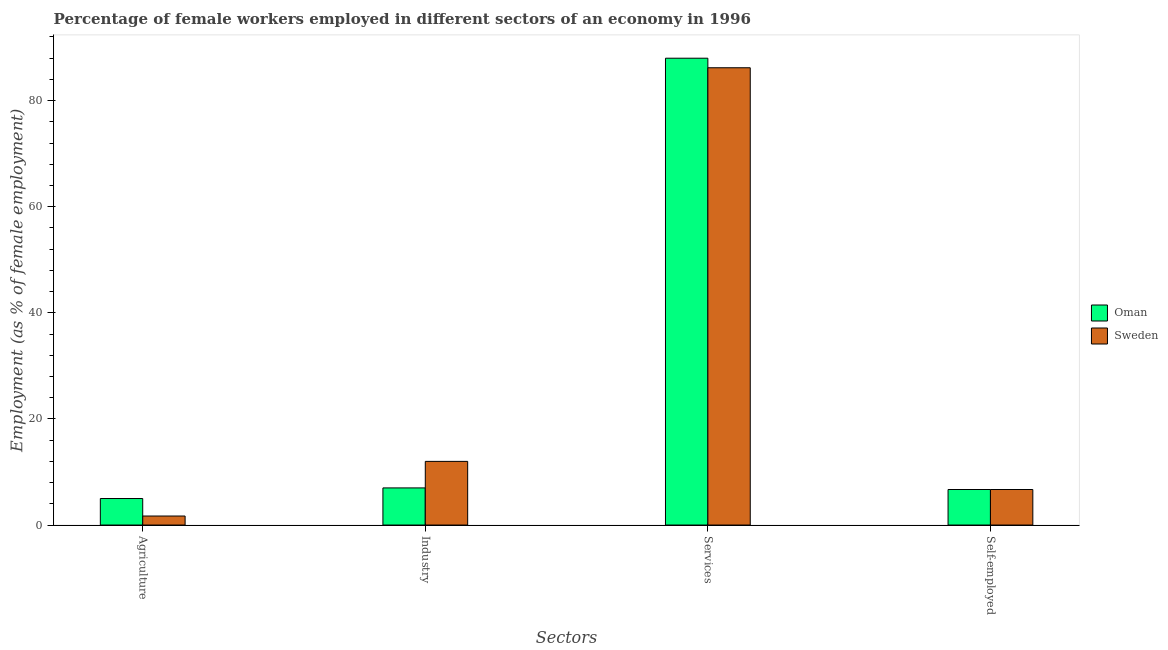Are the number of bars per tick equal to the number of legend labels?
Give a very brief answer. Yes. Are the number of bars on each tick of the X-axis equal?
Offer a terse response. Yes. How many bars are there on the 2nd tick from the left?
Provide a succinct answer. 2. How many bars are there on the 1st tick from the right?
Give a very brief answer. 2. What is the label of the 4th group of bars from the left?
Offer a very short reply. Self-employed. What is the percentage of self employed female workers in Oman?
Offer a terse response. 6.7. In which country was the percentage of female workers in services maximum?
Give a very brief answer. Oman. In which country was the percentage of female workers in services minimum?
Give a very brief answer. Sweden. What is the total percentage of female workers in agriculture in the graph?
Offer a very short reply. 6.7. What is the difference between the percentage of female workers in services in Oman and that in Sweden?
Make the answer very short. 1.8. What is the difference between the percentage of female workers in agriculture in Oman and the percentage of female workers in services in Sweden?
Give a very brief answer. -81.2. What is the average percentage of female workers in services per country?
Offer a terse response. 87.1. What is the difference between the percentage of female workers in industry and percentage of self employed female workers in Sweden?
Give a very brief answer. 5.3. In how many countries, is the percentage of female workers in industry greater than 36 %?
Your answer should be very brief. 0. What is the ratio of the percentage of female workers in industry in Oman to that in Sweden?
Provide a succinct answer. 0.58. Is the percentage of female workers in industry in Oman less than that in Sweden?
Your response must be concise. Yes. Is the difference between the percentage of female workers in agriculture in Oman and Sweden greater than the difference between the percentage of female workers in industry in Oman and Sweden?
Offer a very short reply. Yes. What is the difference between the highest and the second highest percentage of female workers in agriculture?
Keep it short and to the point. 3.3. What is the difference between the highest and the lowest percentage of female workers in services?
Your answer should be very brief. 1.8. Is it the case that in every country, the sum of the percentage of female workers in agriculture and percentage of female workers in services is greater than the sum of percentage of female workers in industry and percentage of self employed female workers?
Make the answer very short. Yes. What does the 2nd bar from the left in Services represents?
Offer a very short reply. Sweden. What does the 1st bar from the right in Services represents?
Make the answer very short. Sweden. Is it the case that in every country, the sum of the percentage of female workers in agriculture and percentage of female workers in industry is greater than the percentage of female workers in services?
Your response must be concise. No. How many bars are there?
Provide a succinct answer. 8. Does the graph contain grids?
Your answer should be very brief. No. Where does the legend appear in the graph?
Your answer should be compact. Center right. How many legend labels are there?
Your answer should be compact. 2. What is the title of the graph?
Offer a terse response. Percentage of female workers employed in different sectors of an economy in 1996. Does "Ghana" appear as one of the legend labels in the graph?
Make the answer very short. No. What is the label or title of the X-axis?
Ensure brevity in your answer.  Sectors. What is the label or title of the Y-axis?
Offer a terse response. Employment (as % of female employment). What is the Employment (as % of female employment) of Sweden in Agriculture?
Your response must be concise. 1.7. What is the Employment (as % of female employment) in Sweden in Industry?
Make the answer very short. 12. What is the Employment (as % of female employment) in Sweden in Services?
Offer a very short reply. 86.2. What is the Employment (as % of female employment) of Oman in Self-employed?
Provide a short and direct response. 6.7. What is the Employment (as % of female employment) in Sweden in Self-employed?
Your answer should be compact. 6.7. Across all Sectors, what is the maximum Employment (as % of female employment) in Oman?
Provide a succinct answer. 88. Across all Sectors, what is the maximum Employment (as % of female employment) in Sweden?
Ensure brevity in your answer.  86.2. Across all Sectors, what is the minimum Employment (as % of female employment) of Oman?
Your response must be concise. 5. Across all Sectors, what is the minimum Employment (as % of female employment) of Sweden?
Offer a terse response. 1.7. What is the total Employment (as % of female employment) in Oman in the graph?
Offer a very short reply. 106.7. What is the total Employment (as % of female employment) in Sweden in the graph?
Give a very brief answer. 106.6. What is the difference between the Employment (as % of female employment) in Oman in Agriculture and that in Industry?
Offer a very short reply. -2. What is the difference between the Employment (as % of female employment) of Sweden in Agriculture and that in Industry?
Provide a short and direct response. -10.3. What is the difference between the Employment (as % of female employment) in Oman in Agriculture and that in Services?
Provide a short and direct response. -83. What is the difference between the Employment (as % of female employment) of Sweden in Agriculture and that in Services?
Offer a very short reply. -84.5. What is the difference between the Employment (as % of female employment) in Oman in Industry and that in Services?
Provide a succinct answer. -81. What is the difference between the Employment (as % of female employment) in Sweden in Industry and that in Services?
Provide a short and direct response. -74.2. What is the difference between the Employment (as % of female employment) of Oman in Industry and that in Self-employed?
Provide a short and direct response. 0.3. What is the difference between the Employment (as % of female employment) of Oman in Services and that in Self-employed?
Your answer should be very brief. 81.3. What is the difference between the Employment (as % of female employment) of Sweden in Services and that in Self-employed?
Offer a very short reply. 79.5. What is the difference between the Employment (as % of female employment) of Oman in Agriculture and the Employment (as % of female employment) of Sweden in Services?
Offer a very short reply. -81.2. What is the difference between the Employment (as % of female employment) of Oman in Industry and the Employment (as % of female employment) of Sweden in Services?
Your answer should be compact. -79.2. What is the difference between the Employment (as % of female employment) in Oman in Services and the Employment (as % of female employment) in Sweden in Self-employed?
Provide a succinct answer. 81.3. What is the average Employment (as % of female employment) in Oman per Sectors?
Your answer should be compact. 26.68. What is the average Employment (as % of female employment) in Sweden per Sectors?
Offer a very short reply. 26.65. What is the difference between the Employment (as % of female employment) of Oman and Employment (as % of female employment) of Sweden in Agriculture?
Your response must be concise. 3.3. What is the difference between the Employment (as % of female employment) of Oman and Employment (as % of female employment) of Sweden in Industry?
Ensure brevity in your answer.  -5. What is the difference between the Employment (as % of female employment) of Oman and Employment (as % of female employment) of Sweden in Services?
Ensure brevity in your answer.  1.8. What is the difference between the Employment (as % of female employment) of Oman and Employment (as % of female employment) of Sweden in Self-employed?
Make the answer very short. 0. What is the ratio of the Employment (as % of female employment) of Sweden in Agriculture to that in Industry?
Provide a short and direct response. 0.14. What is the ratio of the Employment (as % of female employment) of Oman in Agriculture to that in Services?
Keep it short and to the point. 0.06. What is the ratio of the Employment (as % of female employment) in Sweden in Agriculture to that in Services?
Provide a short and direct response. 0.02. What is the ratio of the Employment (as % of female employment) in Oman in Agriculture to that in Self-employed?
Provide a short and direct response. 0.75. What is the ratio of the Employment (as % of female employment) of Sweden in Agriculture to that in Self-employed?
Provide a short and direct response. 0.25. What is the ratio of the Employment (as % of female employment) in Oman in Industry to that in Services?
Your response must be concise. 0.08. What is the ratio of the Employment (as % of female employment) of Sweden in Industry to that in Services?
Give a very brief answer. 0.14. What is the ratio of the Employment (as % of female employment) of Oman in Industry to that in Self-employed?
Offer a very short reply. 1.04. What is the ratio of the Employment (as % of female employment) in Sweden in Industry to that in Self-employed?
Ensure brevity in your answer.  1.79. What is the ratio of the Employment (as % of female employment) in Oman in Services to that in Self-employed?
Make the answer very short. 13.13. What is the ratio of the Employment (as % of female employment) of Sweden in Services to that in Self-employed?
Make the answer very short. 12.87. What is the difference between the highest and the second highest Employment (as % of female employment) of Sweden?
Provide a succinct answer. 74.2. What is the difference between the highest and the lowest Employment (as % of female employment) of Oman?
Your answer should be compact. 83. What is the difference between the highest and the lowest Employment (as % of female employment) in Sweden?
Give a very brief answer. 84.5. 